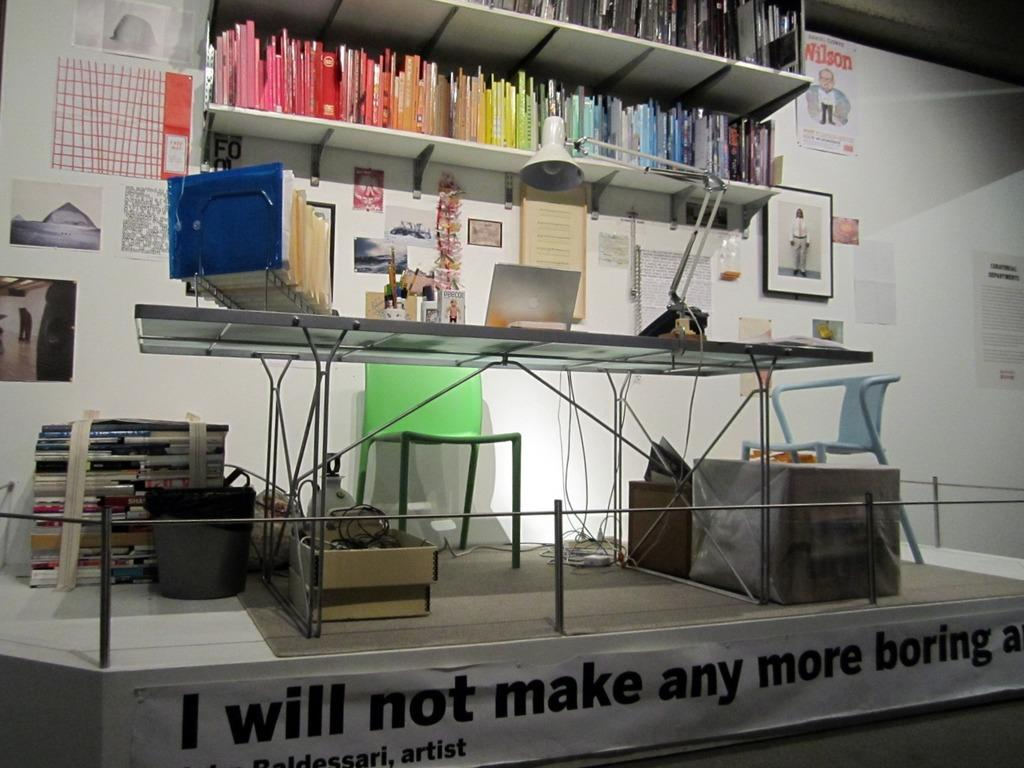<image>
Offer a succinct explanation of the picture presented. A display with a desk on a stand says I will not make any more boring. 